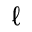Convert formula to latex. <formula><loc_0><loc_0><loc_500><loc_500>\ell</formula> 